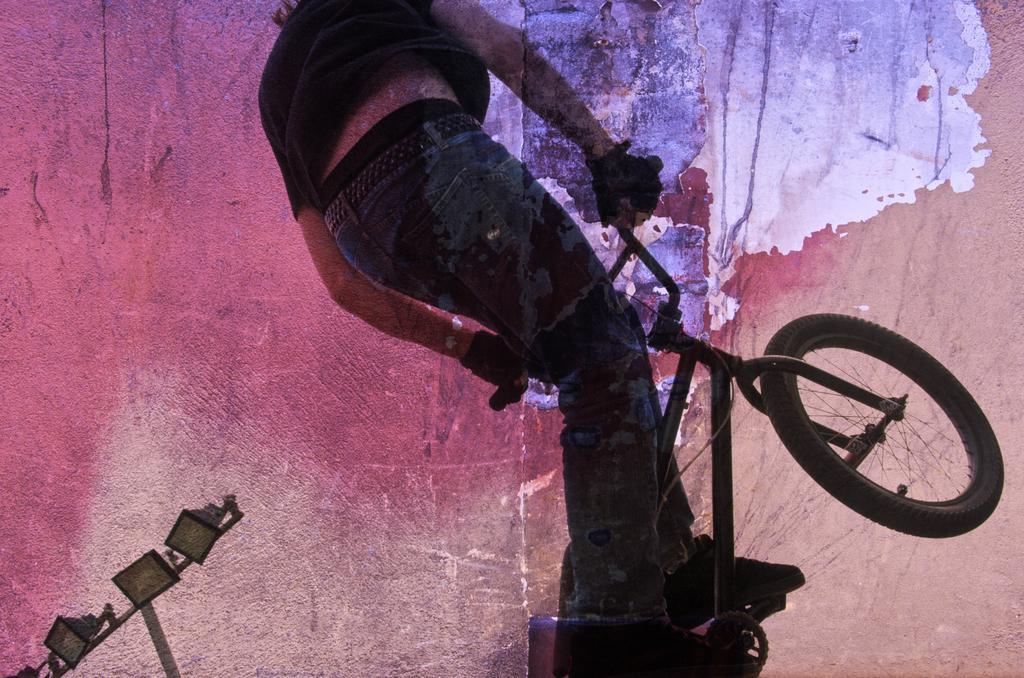What type of artwork is depicted in the image? The image is a painting. Can you describe the subject matter of the painting? There is a person and a cycle in the painting. Are there any additional elements in the painting? Yes, there are lights at the bottom left corner of the painting. Is there a cobweb visible in the painting? There is no mention of a cobweb in the provided facts, so we cannot determine if one is present in the painting. --- Facts: 1. There is a car in the image. 2. The car is red. 3. The car has four wheels. 4. There is a road in the image. 5. The road is paved. Absurd Topics: bird, ocean, mountain Conversation: What is the main subject of the image? The main subject of the image is a car. Can you describe the car's appearance? The car is red and has four wheels. What is the setting of the image? There is a road in the image, and the road is paved. Reasoning: Let's think step by step in order to produce the conversation. We start by identifying the main subject of the image, which is the car. Then, we describe the car's appearance, including its color and the number of wheels. Finally, we mention the setting of the image, which is a paved road. Absurd Question/Answer: Can you see any mountains in the background of the image? There is no mention of mountains in the provided facts, so we cannot determine if any are present in the image. 